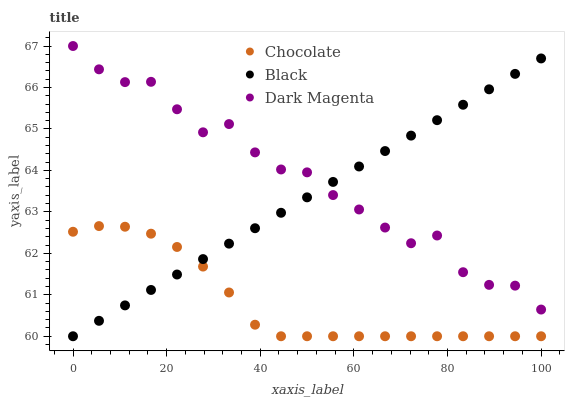Does Chocolate have the minimum area under the curve?
Answer yes or no. Yes. Does Dark Magenta have the maximum area under the curve?
Answer yes or no. Yes. Does Dark Magenta have the minimum area under the curve?
Answer yes or no. No. Does Chocolate have the maximum area under the curve?
Answer yes or no. No. Is Black the smoothest?
Answer yes or no. Yes. Is Dark Magenta the roughest?
Answer yes or no. Yes. Is Chocolate the smoothest?
Answer yes or no. No. Is Chocolate the roughest?
Answer yes or no. No. Does Black have the lowest value?
Answer yes or no. Yes. Does Dark Magenta have the lowest value?
Answer yes or no. No. Does Dark Magenta have the highest value?
Answer yes or no. Yes. Does Chocolate have the highest value?
Answer yes or no. No. Is Chocolate less than Dark Magenta?
Answer yes or no. Yes. Is Dark Magenta greater than Chocolate?
Answer yes or no. Yes. Does Black intersect Chocolate?
Answer yes or no. Yes. Is Black less than Chocolate?
Answer yes or no. No. Is Black greater than Chocolate?
Answer yes or no. No. Does Chocolate intersect Dark Magenta?
Answer yes or no. No. 